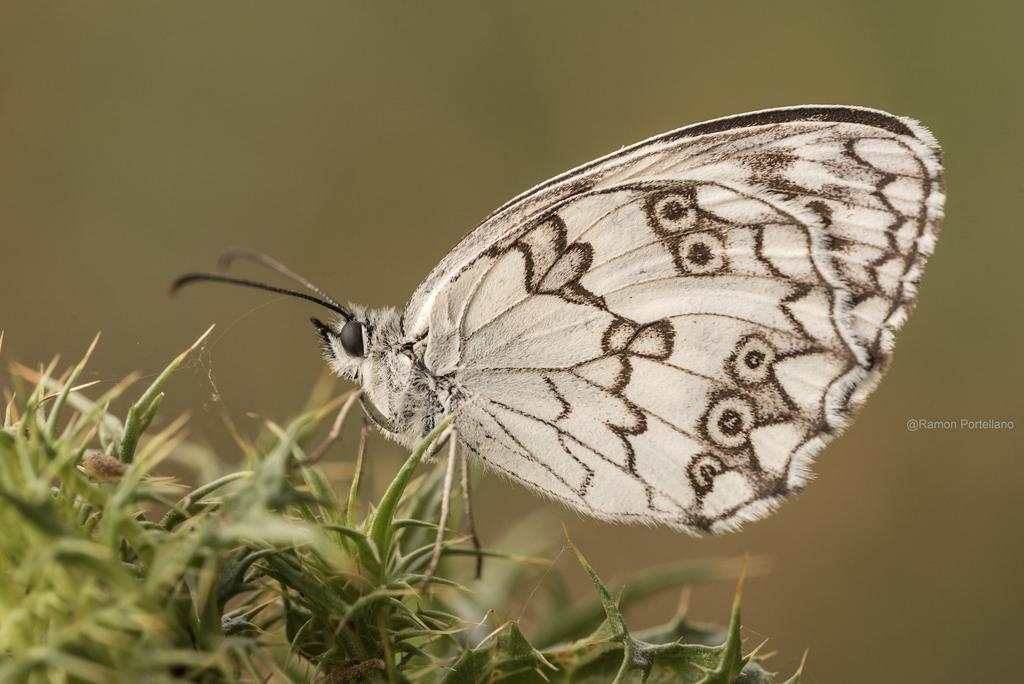What is the main subject of the image? There is a butterfly in the image. Where is the butterfly located? The butterfly is on the grass. What is the price of the floor in the image? There is no floor present in the image, and therefore no price can be determined. 